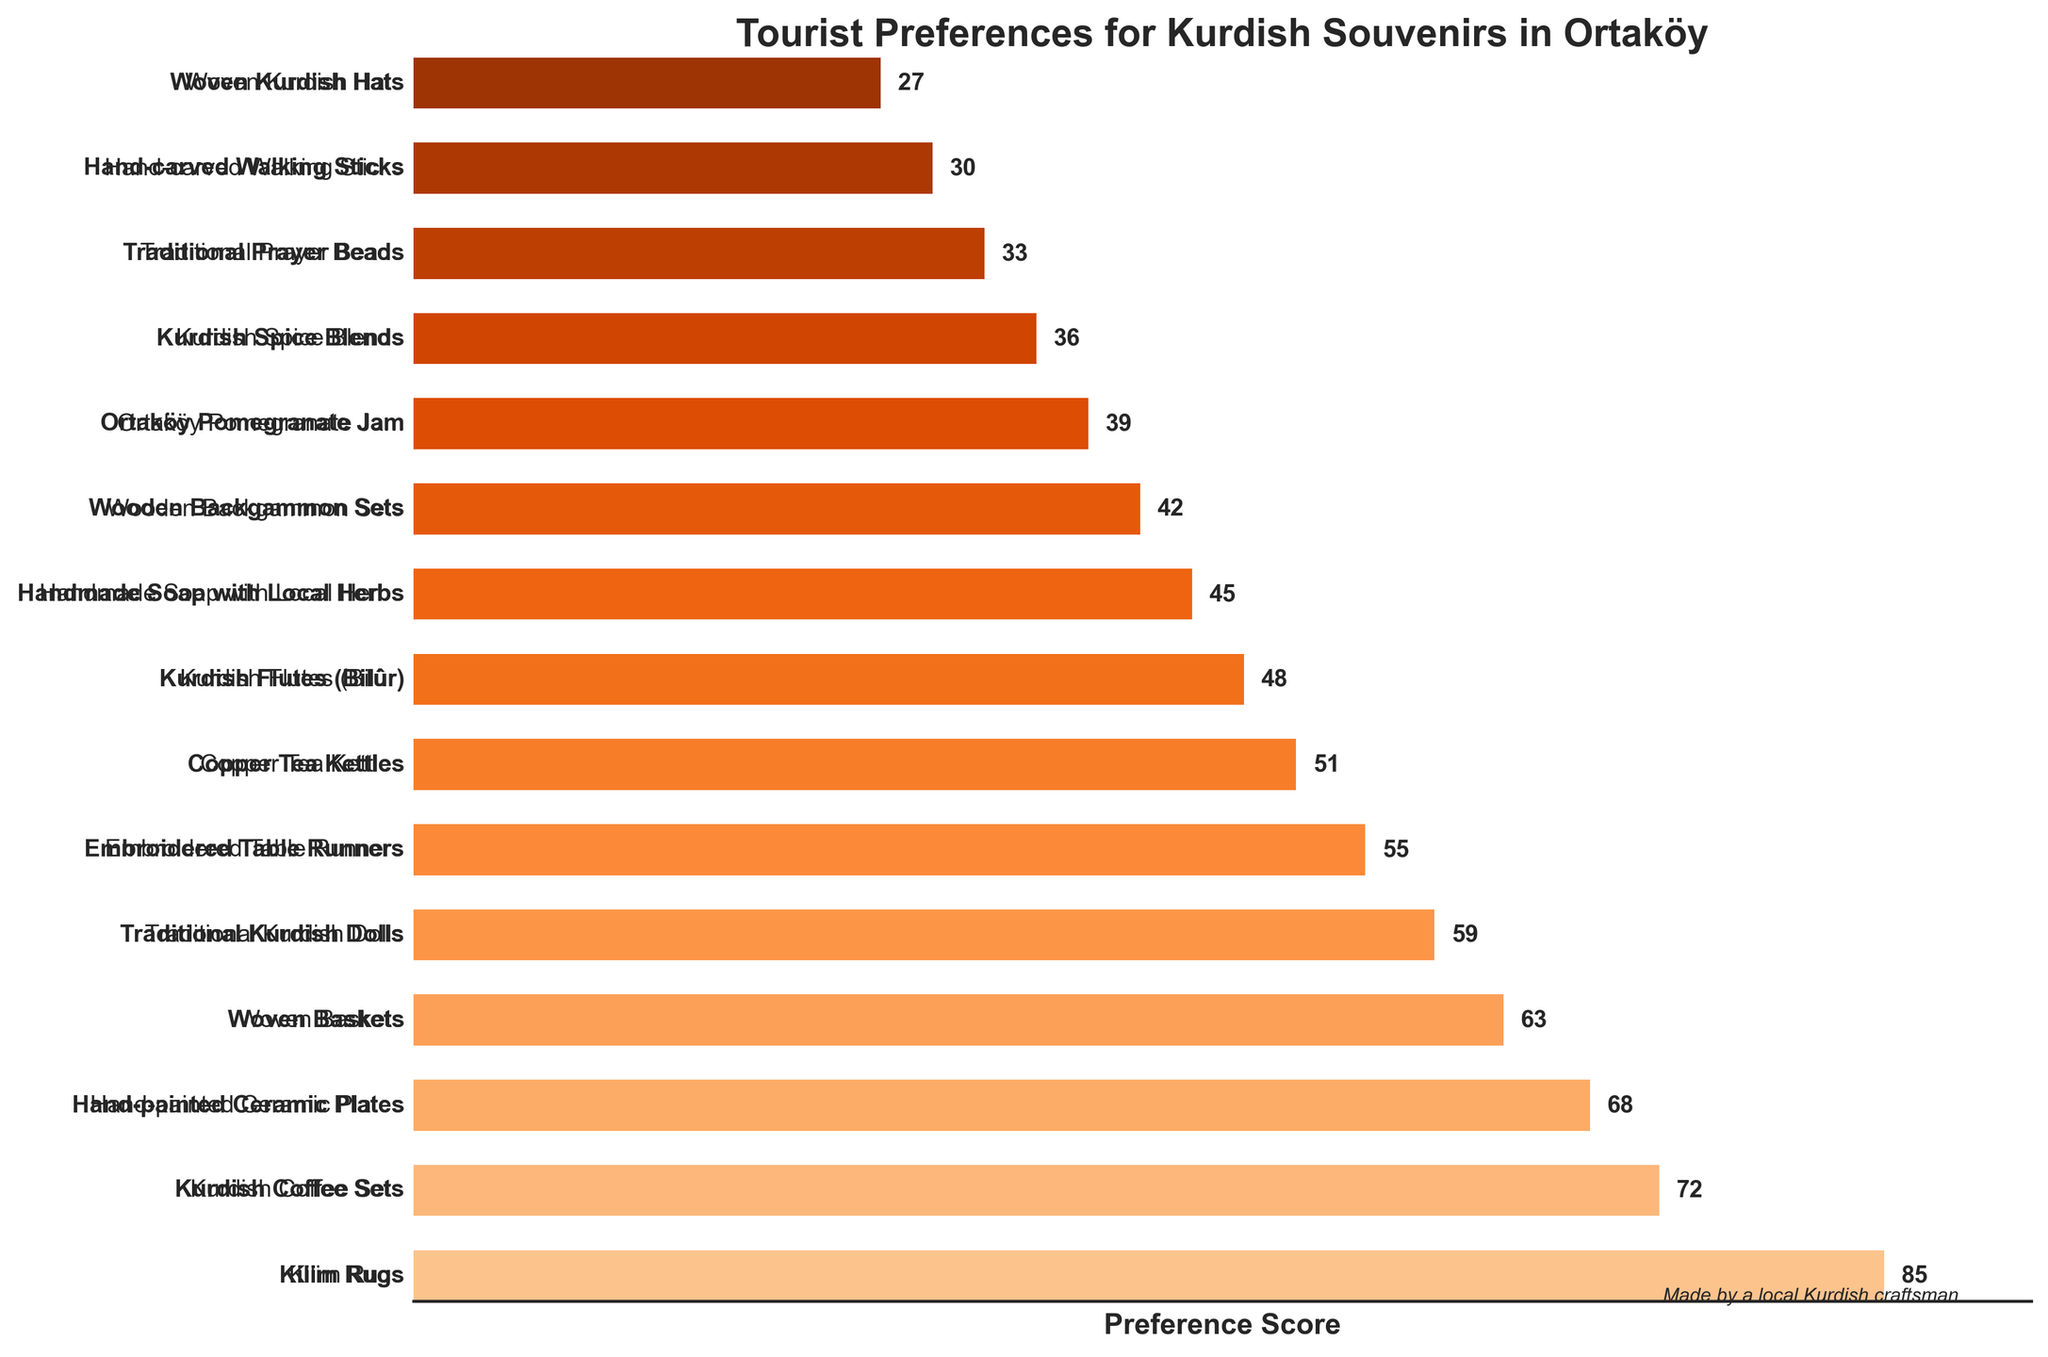Which souvenir has the highest preference score? The bar chart shows "Kilim Rugs" with the longest bar, indicating it has the highest preference score of 85.
Answer: Kilim Rugs Which souvenir has the lowest preference score? The bar chart shows "Woven Kurdish Hats" with the shortest bar, indicating it has the lowest preference score of 27.
Answer: Woven Kurdish Hats What is the total preference score for "Hand-painted Ceramic Plates" and "Traditional Kurdish Dolls"? According to the figure, "Hand-painted Ceramic Plates" has a score of 68, and "Traditional Kurdish Dolls" has a score of 59. Adding these together gives 68 + 59 = 127.
Answer: 127 How much higher is the preference score for "Kurdish Coffee Sets" compared to "Kurdish Flutes (Bilûr)"? The figure shows "Kurdish Coffee Sets" with a score of 72 and "Kurdish Flutes (Bilûr)" with a score of 48. Subtracting these, we get 72 - 48 = 24.
Answer: 24 Which souvenirs have preference scores greater than 50? By inspecting the figure, the souvenirs with scores greater than 50 are: "Kilim Rugs" (85), "Kurdish Coffee Sets" (72), "Hand-painted Ceramic Plates" (68), "Woven Baskets" (63), "Traditional Kurdish Dolls" (59), "Embroidered Table Runners" (55), and "Copper Tea Kettles" (51).
Answer: Kilim Rugs, Kurdish Coffee Sets, Hand-painted Ceramic Plates, Woven Baskets, Traditional Kurdish Dolls, Embroidered Table Runners, Copper Tea Kettles What is the combined preference score for all the souvenirs ending with the word "Sets"? The chart shows two items ending with "Sets": "Kurdish Coffee Sets" (72) and "Wooden Backgammon Sets" (42). Adding these scores, we get 72 + 42 = 114.
Answer: 114 How does the preference score for "Handmade Soap with Local Herbs" compare to the "Ortaköy Pomegranate Jam"? "Handmade Soap with Local Herbs" has a score of 45, while "Ortaköy Pomegranate Jam" has a score of 39. Therefore, "Handmade Soap with Local Herbs" has a higher preference score by 45 - 39 = 6.
Answer: 6 What is the average preference score of all the souvenirs shown in the chart? There are 15 souvenirs with scores: 85, 72, 68, 63, 59, 55, 51, 48, 45, 42, 39, 36, 33, 30, and 27. Summing these gives a total of 753. Dividing by 15, the average score is 753 / 15 = 50.2.
Answer: 50.2 